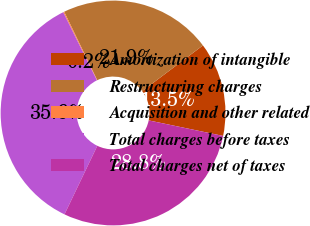Convert chart. <chart><loc_0><loc_0><loc_500><loc_500><pie_chart><fcel>Amortization of intangible<fcel>Restructuring charges<fcel>Acquisition and other related<fcel>Total charges before taxes<fcel>Total charges net of taxes<nl><fcel>13.53%<fcel>21.9%<fcel>0.15%<fcel>35.58%<fcel>28.84%<nl></chart> 